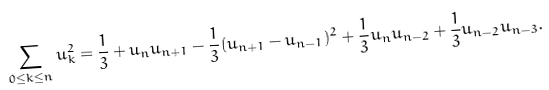Convert formula to latex. <formula><loc_0><loc_0><loc_500><loc_500>\sum _ { 0 \leq k \leq n } u _ { k } ^ { 2 } = \frac { 1 } { 3 } + u _ { n } u _ { n + 1 } - \frac { 1 } { 3 } ( u _ { n + 1 } - u _ { n - 1 } ) ^ { 2 } + \frac { 1 } { 3 } u _ { n } u _ { n - 2 } + \frac { 1 } { 3 } u _ { n - 2 } u _ { n - 3 } .</formula> 